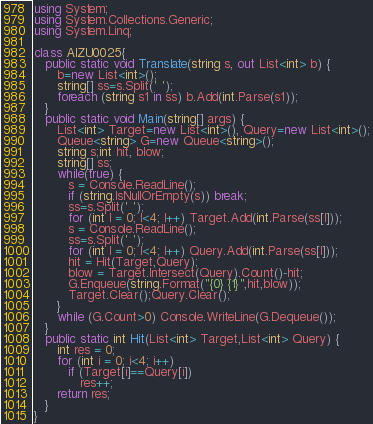<code> <loc_0><loc_0><loc_500><loc_500><_C#_>using System;
using System.Collections.Generic;
using System.Linq;

class AIZU0025{
   public static void Translate(string s, out List<int> b) {
      b=new List<int>();
      string[] ss=s.Split(' ');
      foreach (string s1 in ss) b.Add(int.Parse(s1));
   }
   public static void Main(string[] args) {
      List<int> Target=new List<int>(), Query=new List<int>();
      Queue<string> G=new Queue<string>();
      string s;int hit, blow;
      string[] ss;
      while(true) { 
         s = Console.ReadLine();
         if (string.IsNullOrEmpty(s)) break;
         ss=s.Split(' ');
         for (int I = 0; I<4; I++) Target.Add(int.Parse(ss[I]));
         s = Console.ReadLine();
         ss=s.Split(' ');
         for (int I = 0; I<4; I++) Query.Add(int.Parse(ss[I]));
         hit = Hit(Target,Query);
         blow = Target.Intersect(Query).Count()-hit;
         G.Enqueue(string.Format("{0} {1}",hit,blow));
         Target.Clear();Query.Clear();
      }
      while (G.Count>0) Console.WriteLine(G.Dequeue());
   }
   public static int Hit(List<int> Target,List<int> Query) {
      int res = 0;
      for (int i = 0; i<4; i++)
         if (Target[i]==Query[i]) 
            res++;
      return res;
   }
}</code> 